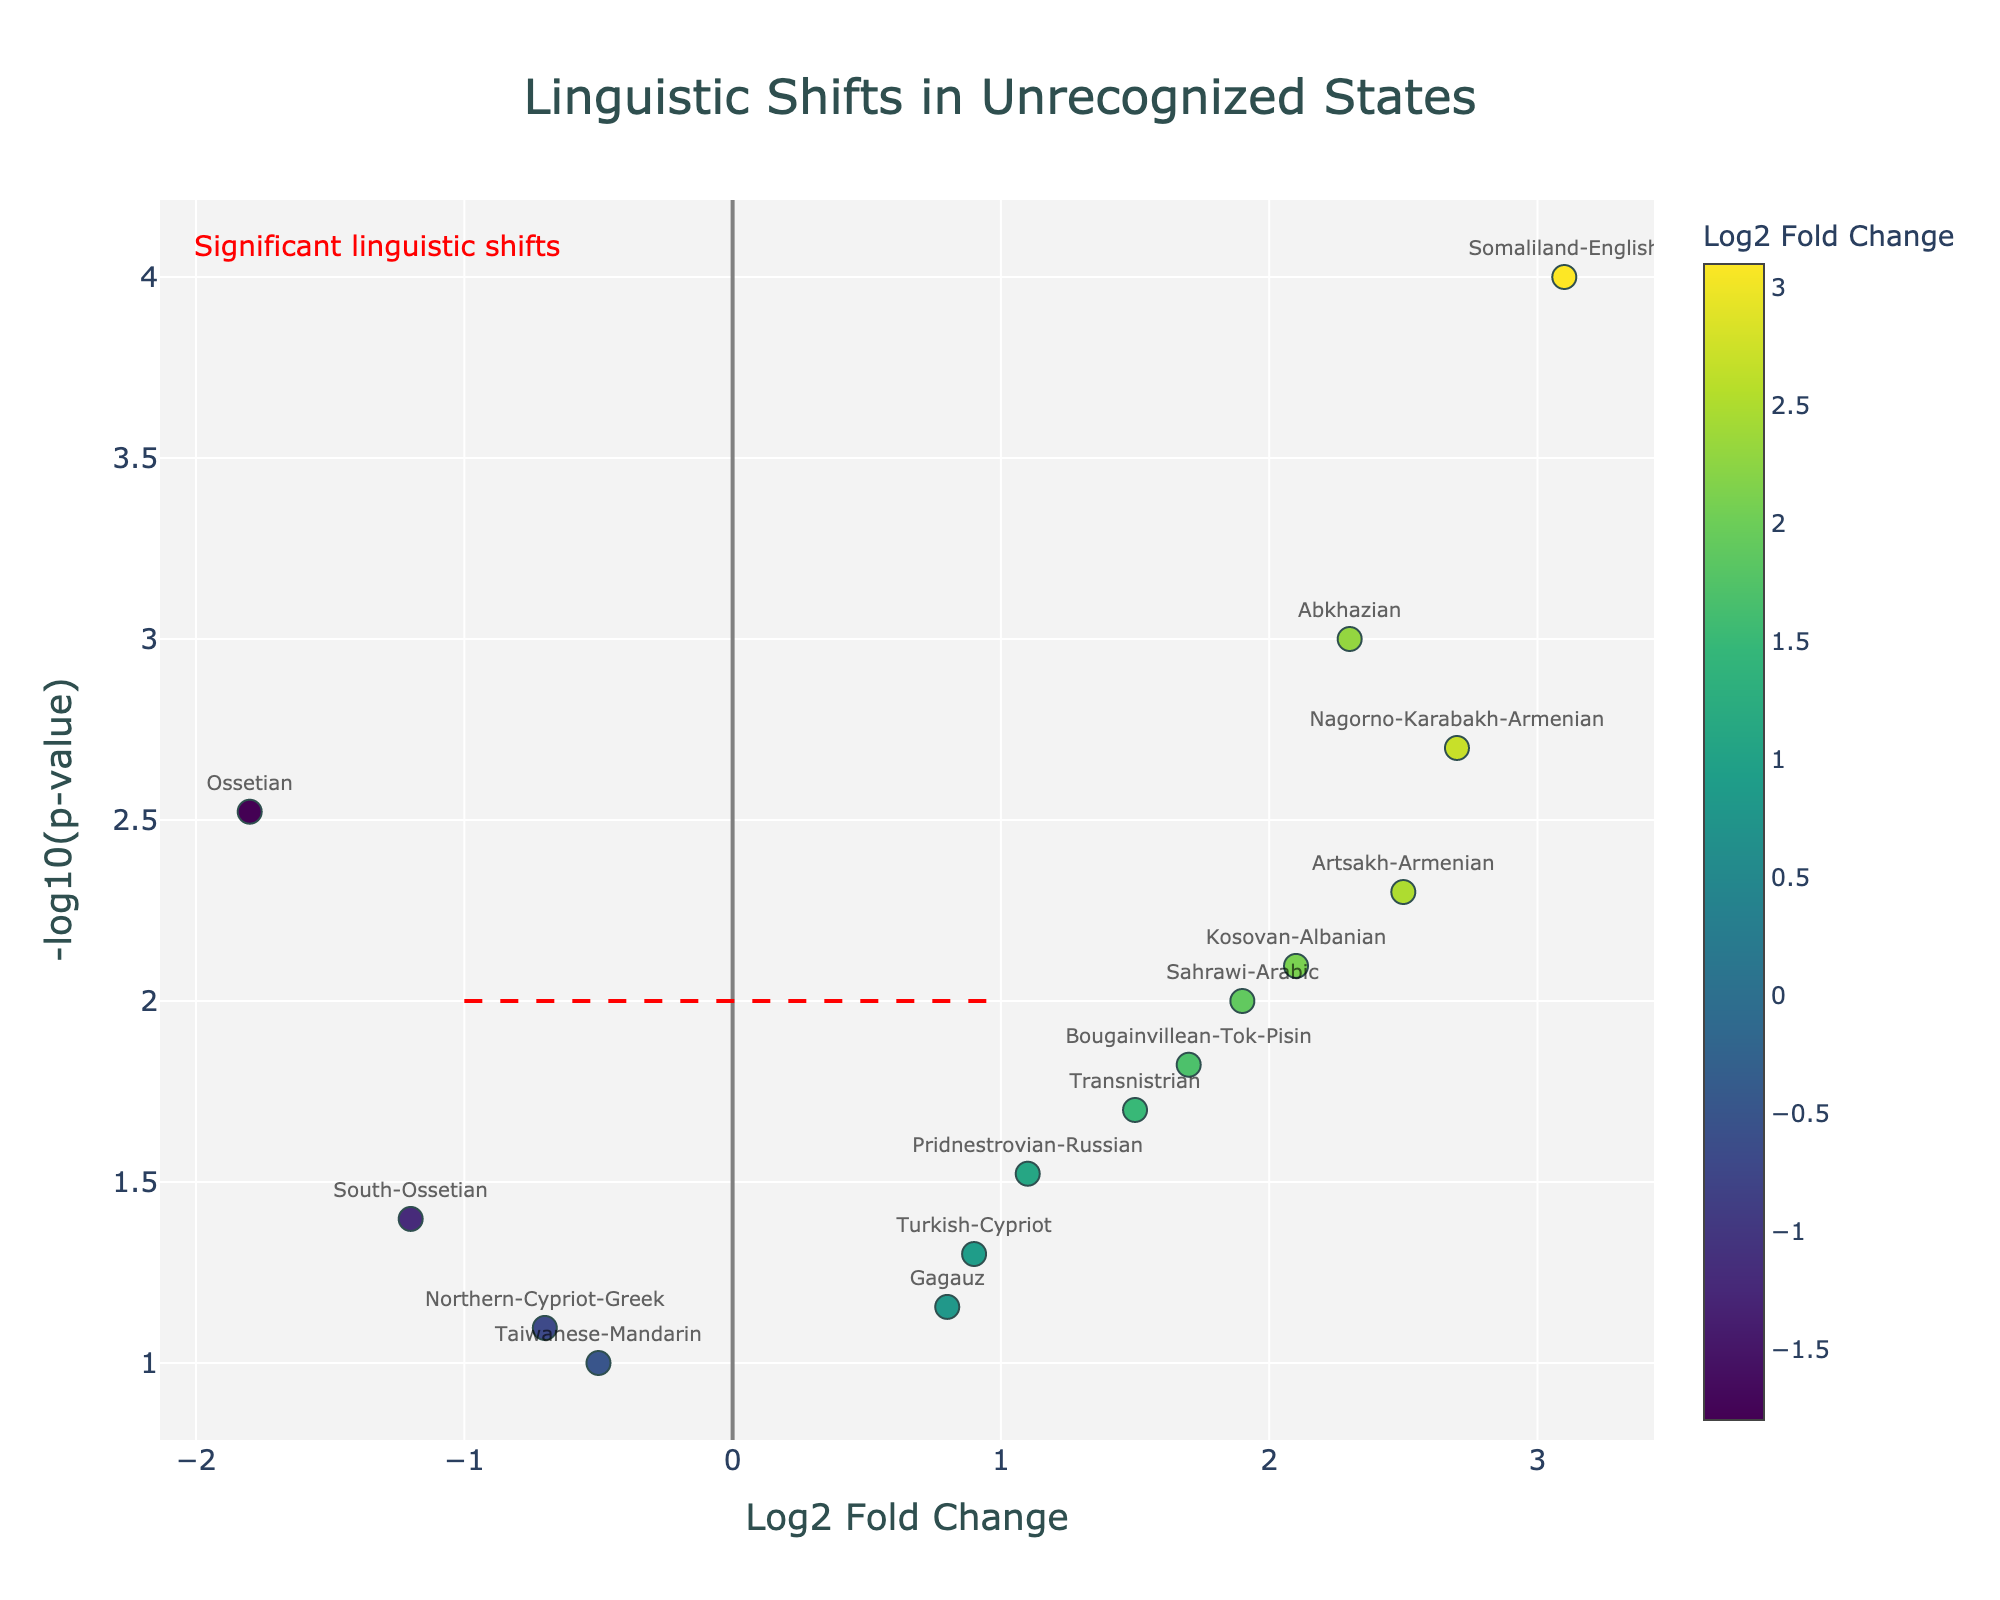What's the title of the figure? The title is usually prominently displayed at the top of the figure. In this case, it reads "Linguistic Shifts in Unrecognized States".
Answer: Linguistic Shifts in Unrecognized States How many data points have a Log2 Fold Change greater than 1? There are several data points in the figure. By referring to those with a Log2 Fold Change greater than 1, we have: Abkhazian, Transnistrian, Somaliland-English, Nagorno-Karabakh-Armenian, Sahrawi-Arabic, Pridnestrovian-Russian, Bougainvillean-Tok-Pisin, and Kosovan-Albanian. There are 8 such data points.
Answer: 8 Which group shows the highest Log2 Fold Change? By looking at the x-axis and identifying the point farthest to the right, we see that "Somaliland-English" has the highest Log2 Fold Change of 3.1.
Answer: Somaliland-English What is the average Log2 Fold Change of the points with p-values less than 0.01? First, identify groups with p-values less than 0.01: Abkhazian, Ossetian, Nagorno-Karabakh-Armenian, Artsakh-Armenian, and Kosovan-Albanian. Then their Log2 Fold Changes: 2.3, -1.8, 2.7, 2.5, and 2.1. Sum them: (2.3 - 1.8 + 2.7 + 2.5 + 2.1) = 7.8. Divide by the number of points: 7.8 / 5 = 1.56.
Answer: 1.56 Which data point is represented with the highest -log10(p-value)? The -log10(p-value) is highest for the point with the smallest p-value. Since "Somaliland-English" has a p-value of 0.0001, it has the highest -log10(p-value).
Answer: Somaliland-English How many data points are labeled with their gene or group name? By counting all labeled data points directly from the figure, each marker has its corresponding label. There are 14 data points.
Answer: 14 Which data point shows the largest negative Log2 Fold Change? By looking at the x-axis and identifying the point farthest to the left, it is "Ossetian" with a Log2 Fold Change of -1.8.
Answer: Ossetian Are there more data points with positive or negative Log2 Fold Change? Count the number of points to the right of the y-axis (positive) and to the left (negative). Positive Log2 Fold Change: 9, Negative Log2 Fold Change: 5. There are more positive Log2 Fold Change data points.
Answer: Positive What is the approximate p-value threshold indicated by the dashed horizontal line? The dashed line intersects the y-axis, and is placed at -log10(p-value) = 2. Inverting it gives p-value ≈ 10^-2 = 0.01.
Answer: 0.01 